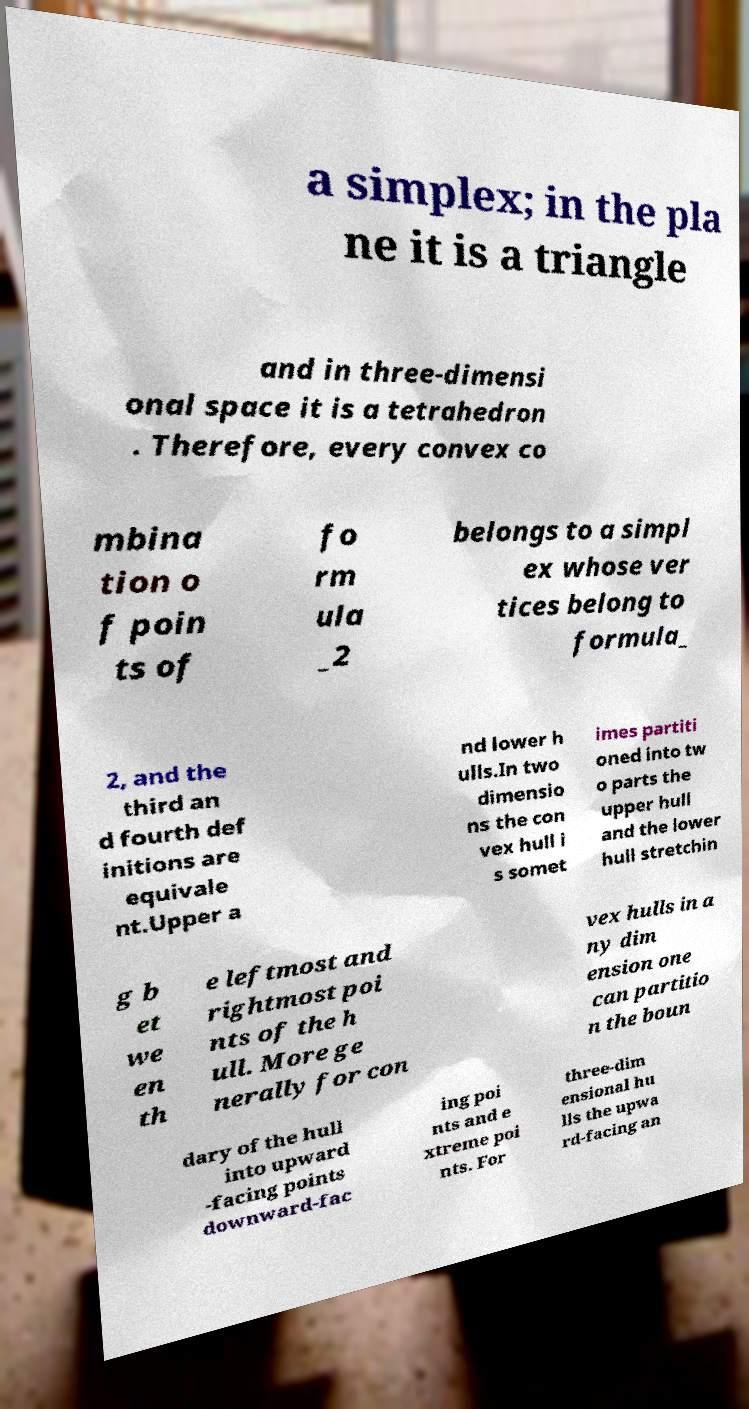There's text embedded in this image that I need extracted. Can you transcribe it verbatim? a simplex; in the pla ne it is a triangle and in three-dimensi onal space it is a tetrahedron . Therefore, every convex co mbina tion o f poin ts of fo rm ula _2 belongs to a simpl ex whose ver tices belong to formula_ 2, and the third an d fourth def initions are equivale nt.Upper a nd lower h ulls.In two dimensio ns the con vex hull i s somet imes partiti oned into tw o parts the upper hull and the lower hull stretchin g b et we en th e leftmost and rightmost poi nts of the h ull. More ge nerally for con vex hulls in a ny dim ension one can partitio n the boun dary of the hull into upward -facing points downward-fac ing poi nts and e xtreme poi nts. For three-dim ensional hu lls the upwa rd-facing an 